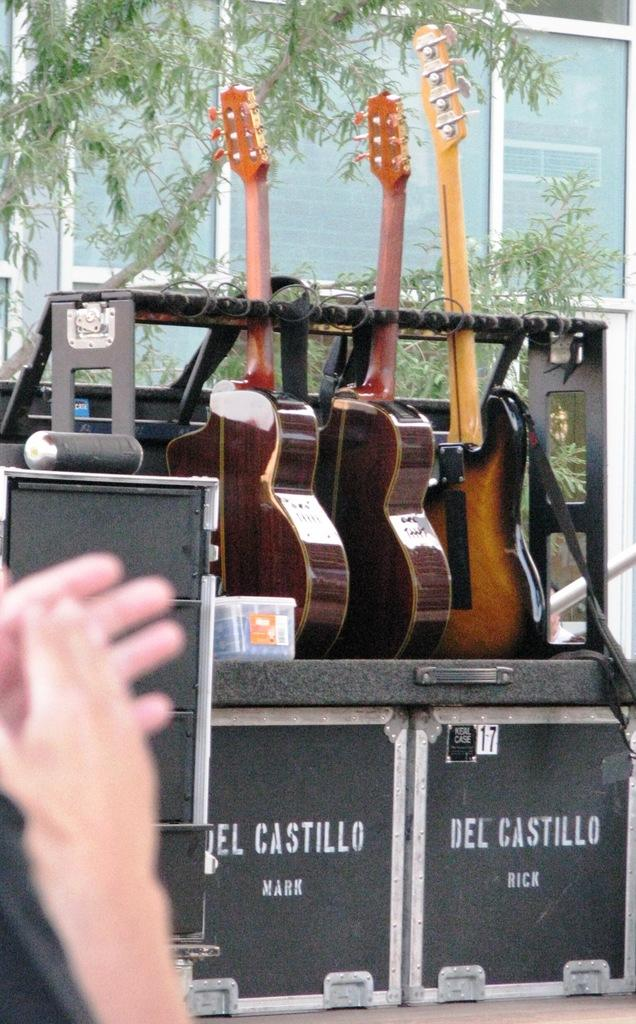What objects are hanging above the boxes in the image? There are guitars above the boxes in the image. What is located beside the guitar? There is a container beside the guitar. What type of vegetation can be seen in the image? There is a tree in the image. What type of building is present in the image? There is a building with glass doors in the image. Can you tell me how many flights are taking off from the tree in the image? There are no flights present in the image, as it features a tree and not an airport or any aircraft. What type of amusement can be seen in the image? There is: There is no amusement park or any amusement-related objects present in the image; it features guitars, boxes, a container, a tree, and a building with glass doors. 